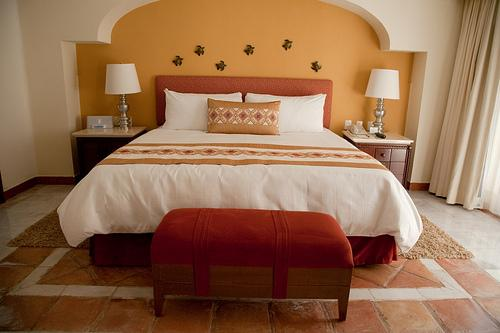Enumerate the types of lamps in the room. There are silver table lamps with ivory shades, and small white and metal lamps on both sides of the bed. Can you tell me the colors of the sheets on the bed? The sheets on the bed are orange and white. Mention the color and type of pillows on the bed. There are white pillows and an orange pillow on the bed. In a poetic manner, describe the atmosphere created by the sunlight in the room. Sunlight gently caresses the room, casting a warm glow and bringing life to every corner. Evaluate the degree of decoration and choice of colors in the bedroom. The bedroom is warmly colored and well decorated, with a mix of orange, white, and brown tones. Describe the bedroom elements that provide a rich and plush vibe. The plush and richly red ottoman and the richly red bedskirt contribute to a luxurious atmosphere. What pattern can be observed on the floor and what colors are prominent? The floor has a brown and white tiled pattern. List the different types of furniture found in the bedroom and their locations. There is an orange fabric headboard, dark hardwood nightstand with a white surface, and maroon and wooden bench. What type of curtains are present in the room and what are their colors? The curtains are offwhite, the sheers are ivory, and there are long white fabric curtains. Count the number of turtles present in the scene. There are several decor turtles on the wall. Write a caption for the lamps on the nightstands. Pair of silver lamps with white shades What is the color scheme of the sheets on the bed? Orange and white How many decorative turtles are on the wall? A group of decor turtles Do the floor tiles have a pattern? If so, describe it. Yes, they are brown and white tiles Create a caption that describes the headboard and its color. Orange fabric headboard Is there a green pillow on the bed? No, it's not mentioned in the image. Choose the correct description of the ottoman: a) plain red b) richly red and plush c) green and patterned b) richly red and plush Describe the flooring in the room. Brown and white tiled floor What color is the background of the decorative birds? Orange What is the material of the nightstand surface? White surface What is the position of the tiny turtle decorations? On the yellow wall What color is the rug under the bed? Brown What type of rug is near the bed? A fuzzy rug Describe the appearance of the pillow in the center of the bed. Orange tuft Describe the bench in the room. Maroon and wooden bench How many pillows are on the bed? Five What type of telephone is in the room? A white corded telephone What is the color of the curtains and sheers? Curtains are off-white, sheers are ivory Describe the curtains in the room. Off-white curtains and ivory sheers What is the fabric of the seat? Fabric covered What is the color of the bedspread? White and brown 